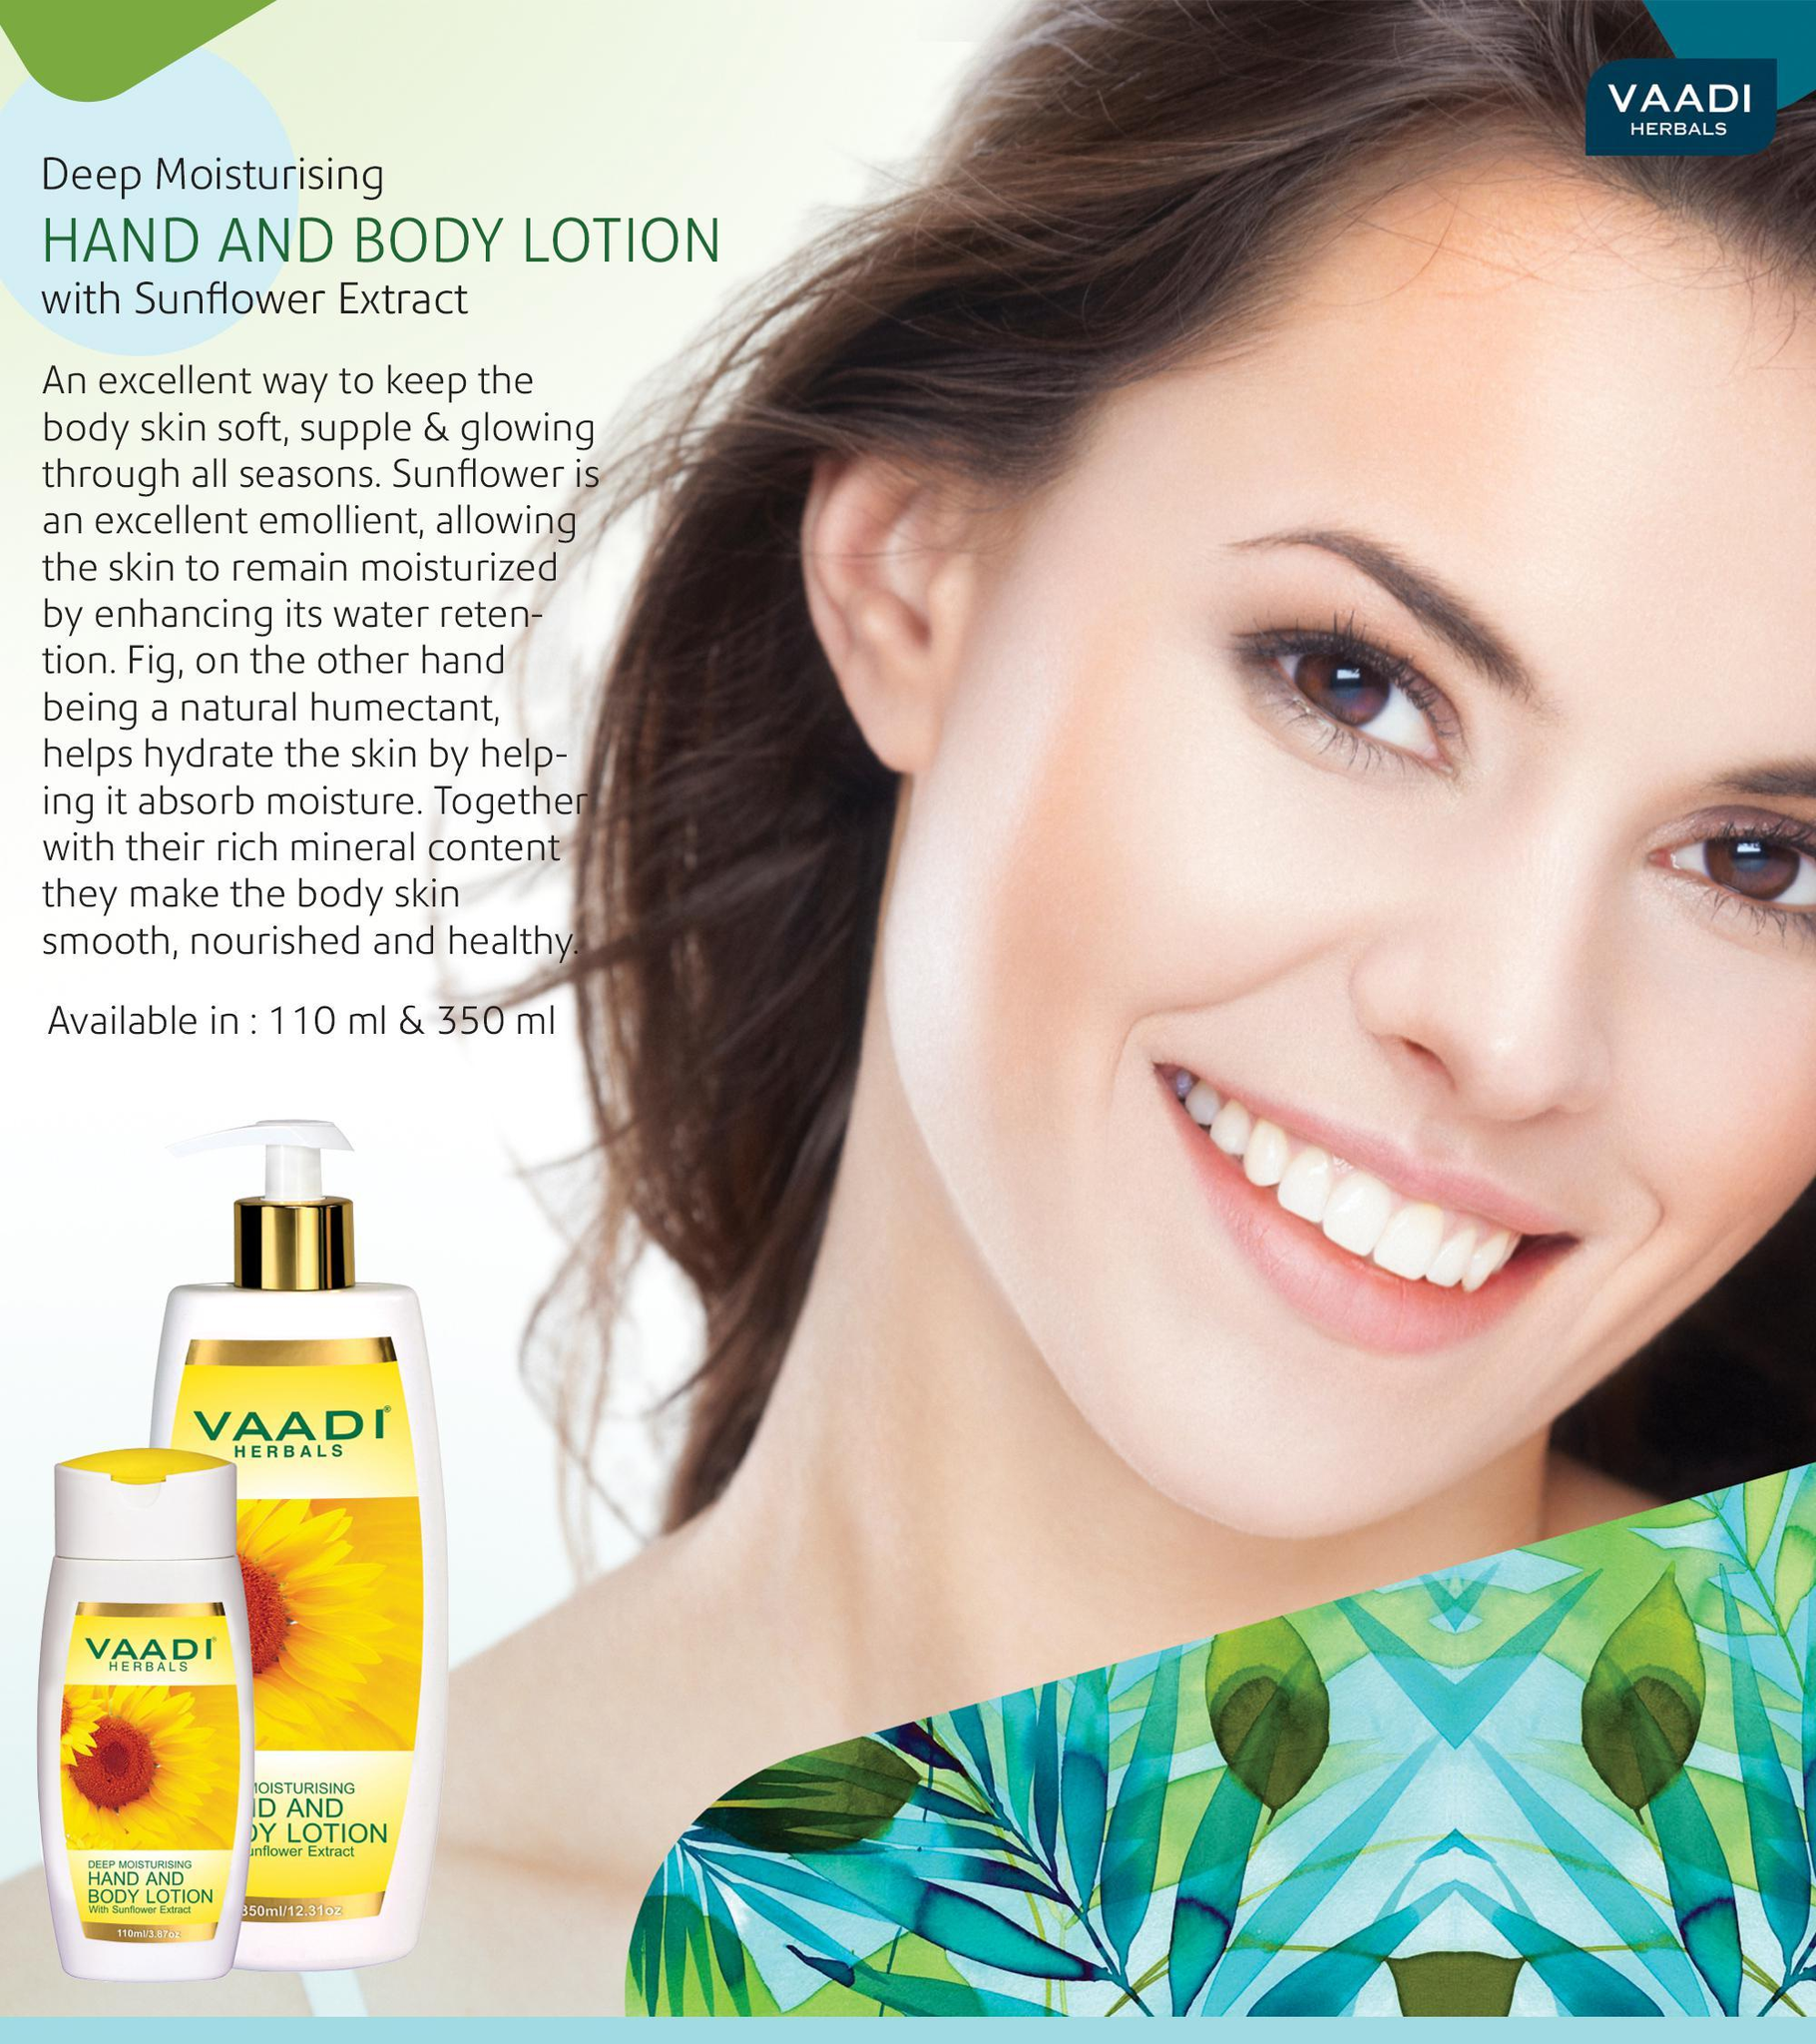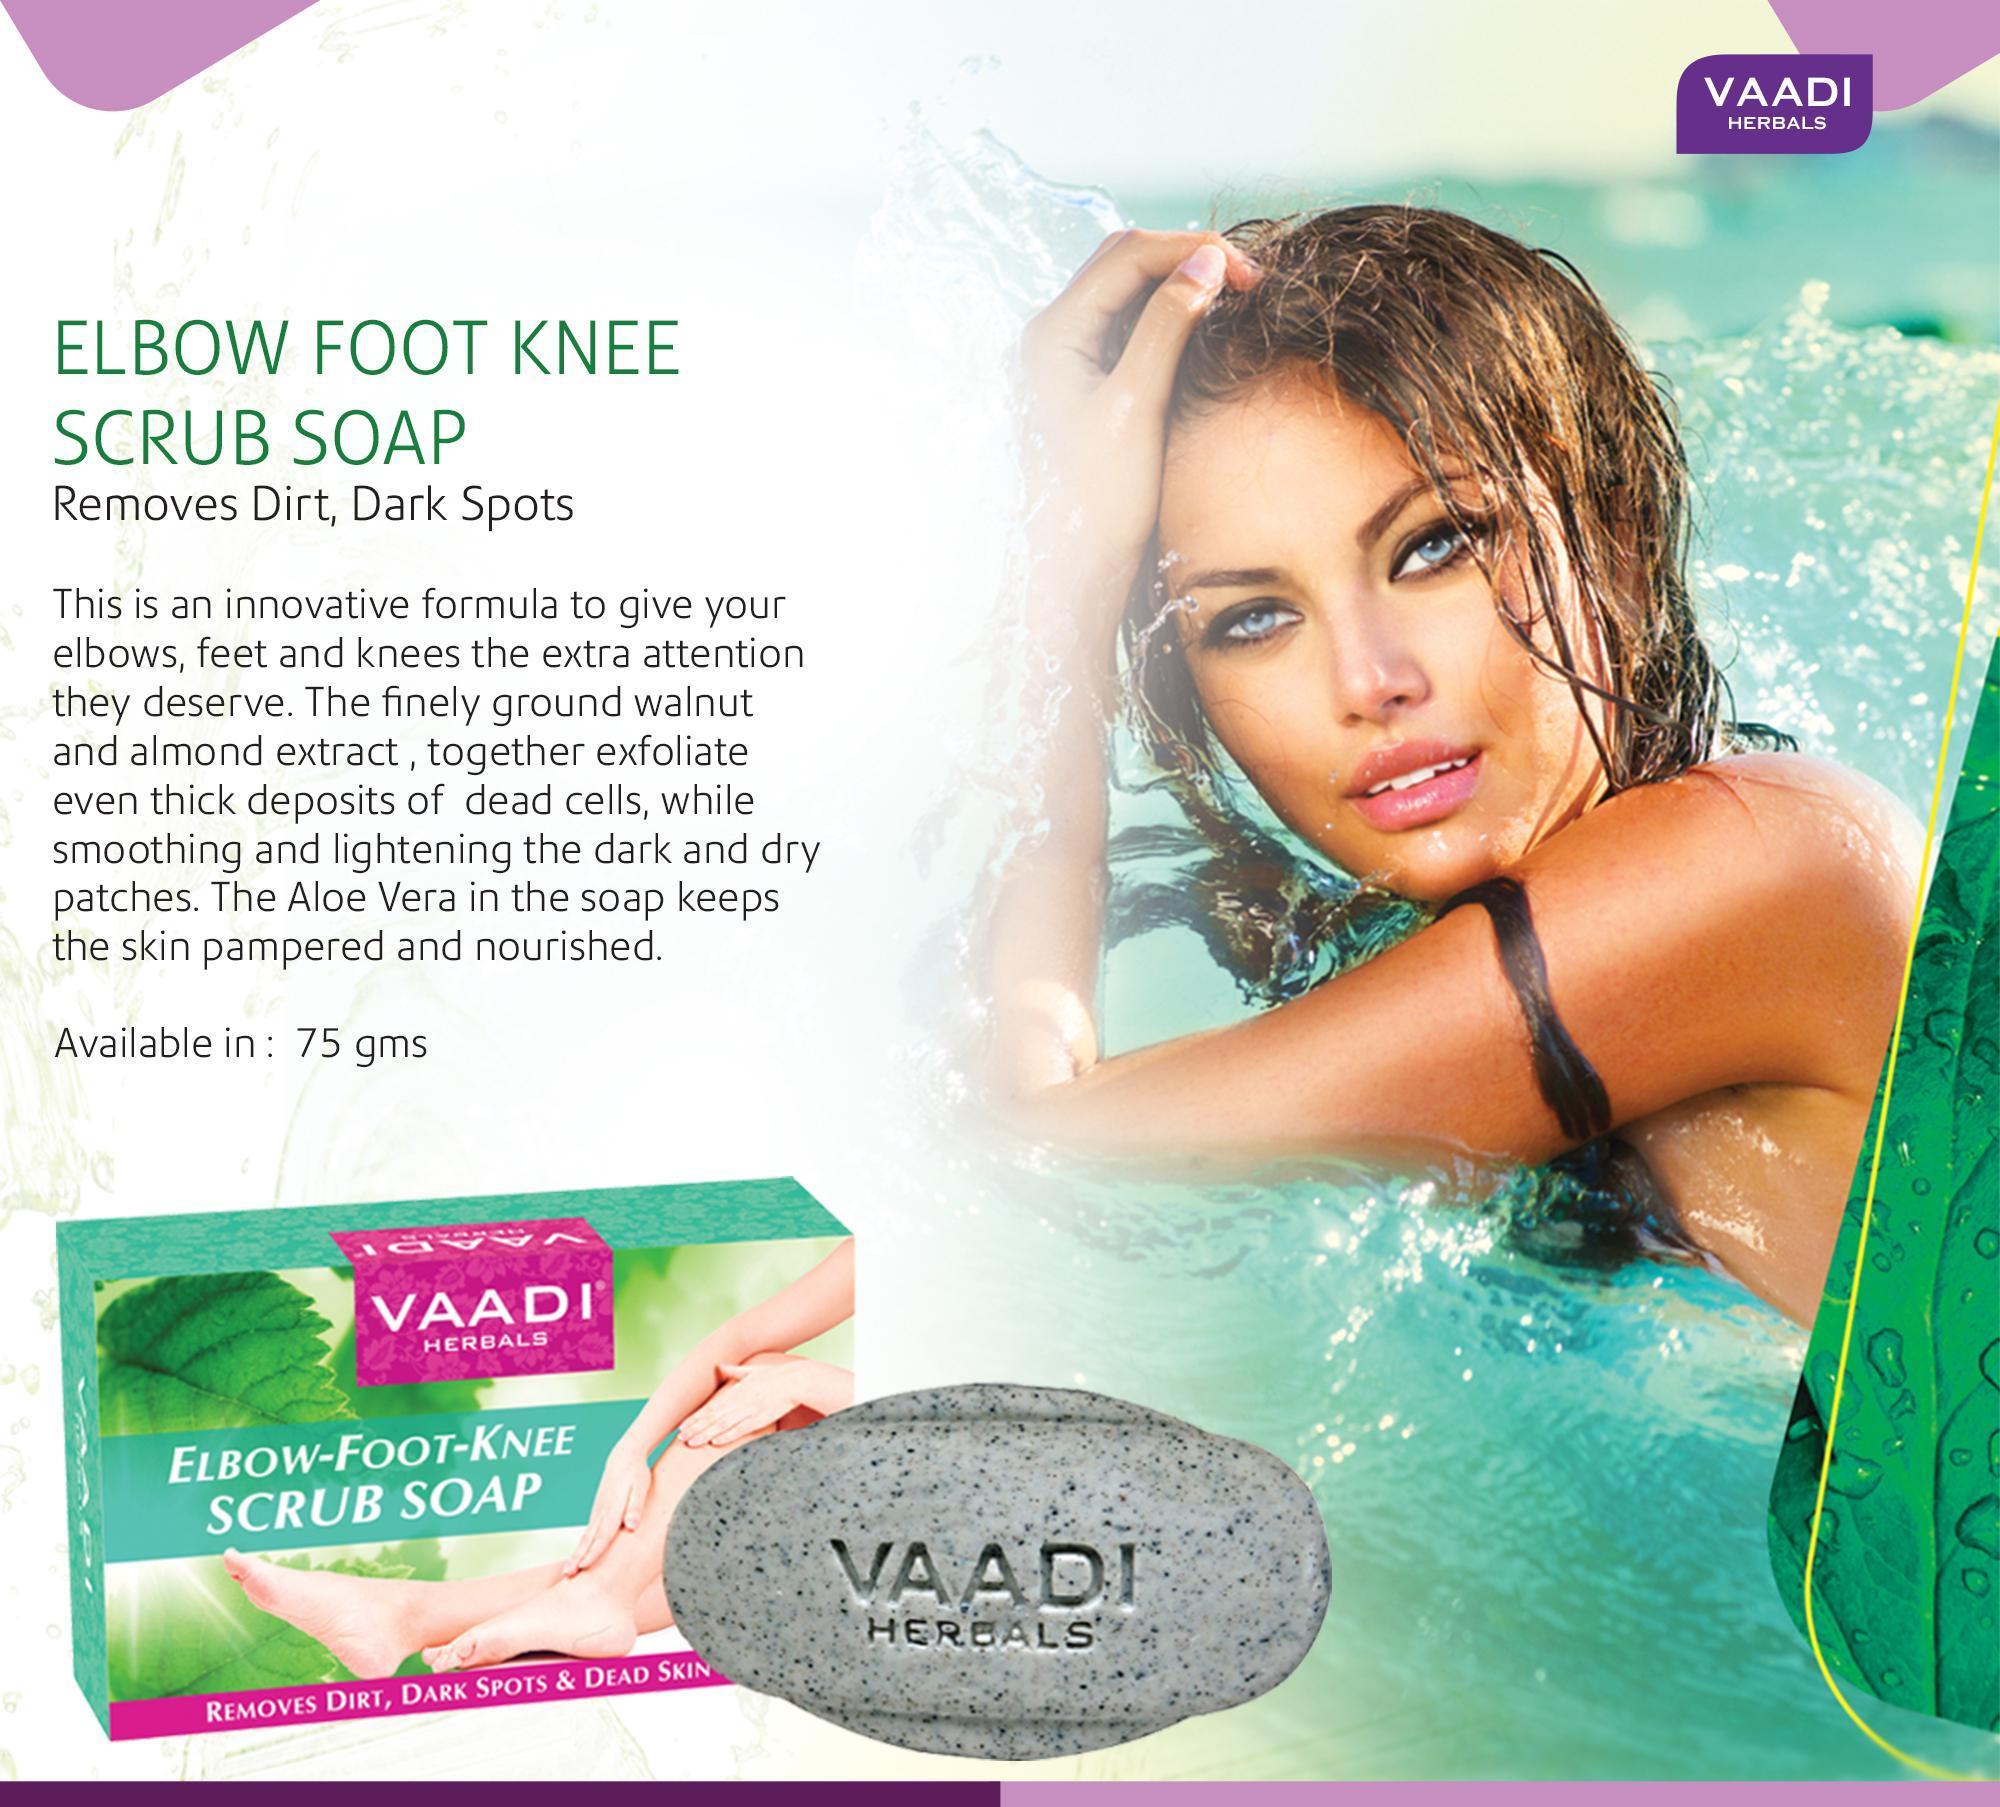The first image is the image on the left, the second image is the image on the right. Analyze the images presented: Is the assertion "An ad image shows a model with slicked-back hair holding exactly one hand on her cheek." valid? Answer yes or no. No. 